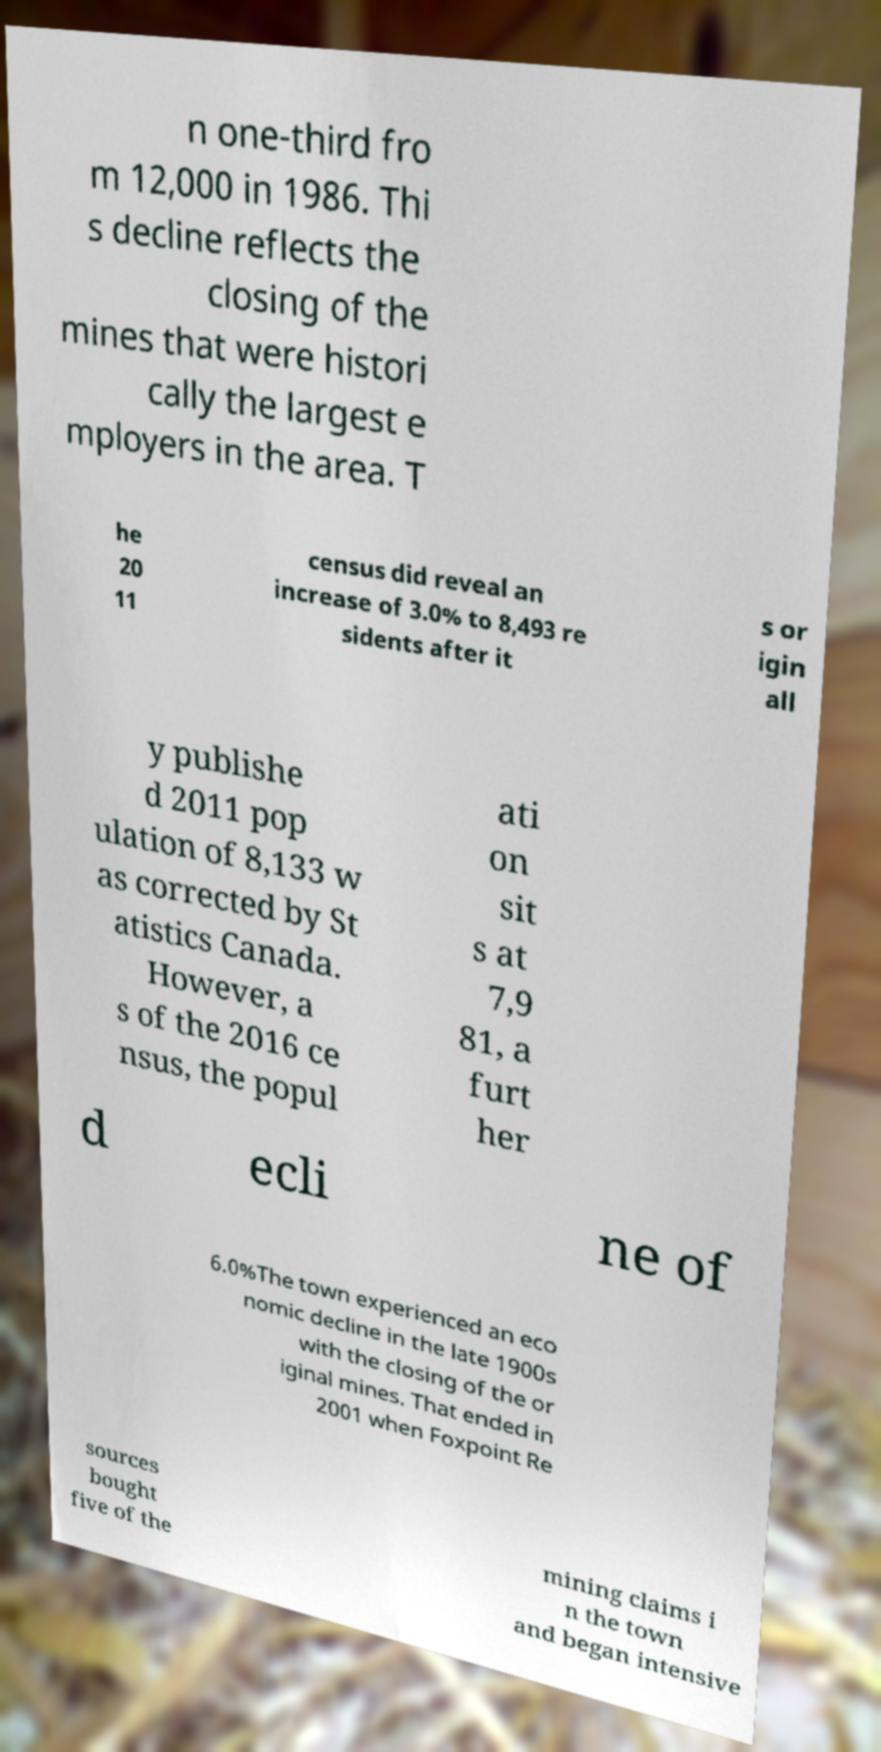Please identify and transcribe the text found in this image. n one-third fro m 12,000 in 1986. Thi s decline reflects the closing of the mines that were histori cally the largest e mployers in the area. T he 20 11 census did reveal an increase of 3.0% to 8,493 re sidents after it s or igin all y publishe d 2011 pop ulation of 8,133 w as corrected by St atistics Canada. However, a s of the 2016 ce nsus, the popul ati on sit s at 7,9 81, a furt her d ecli ne of 6.0%The town experienced an eco nomic decline in the late 1900s with the closing of the or iginal mines. That ended in 2001 when Foxpoint Re sources bought five of the mining claims i n the town and began intensive 